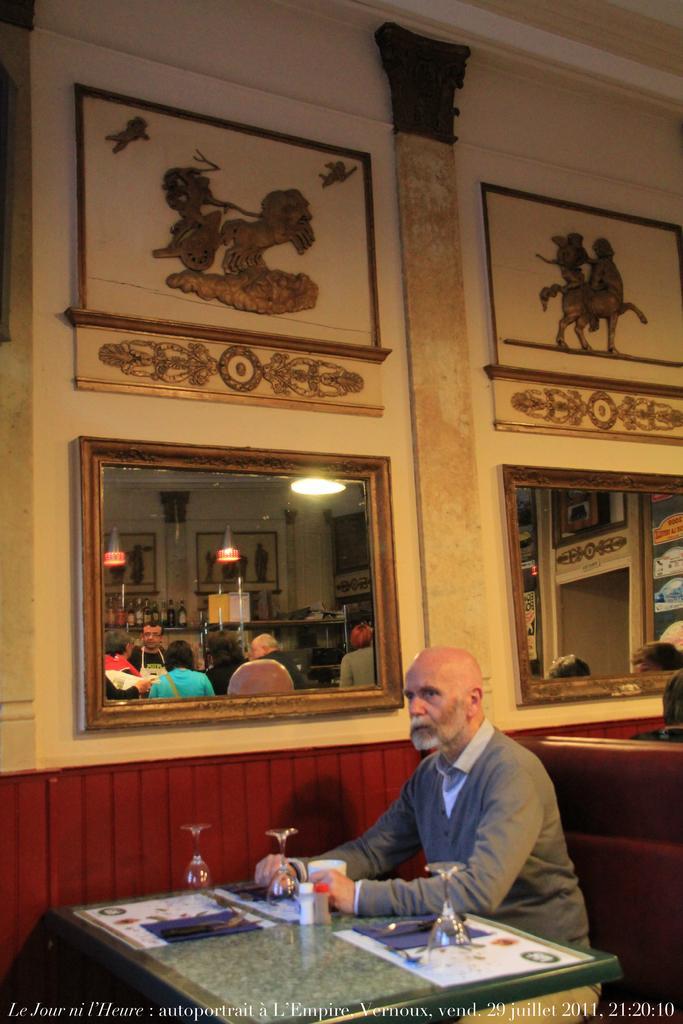How would you summarize this image in a sentence or two? This is the picture of a room. In this image there is a man sitting and there are glasses and there are objects on the table. At the back there are mirrors and frames on the wall and there is reflection of group of people and lights and objects on the mirrors. At the bottom there is text. 